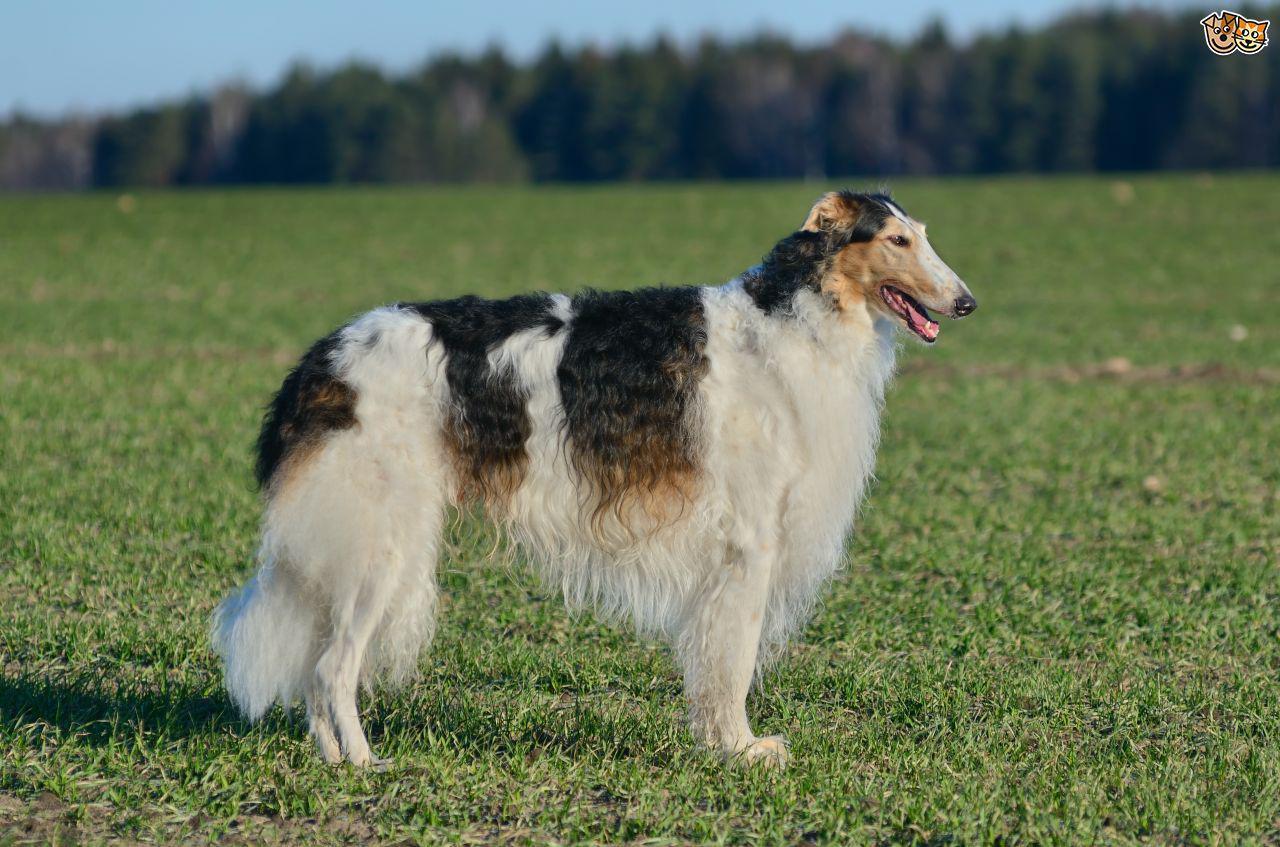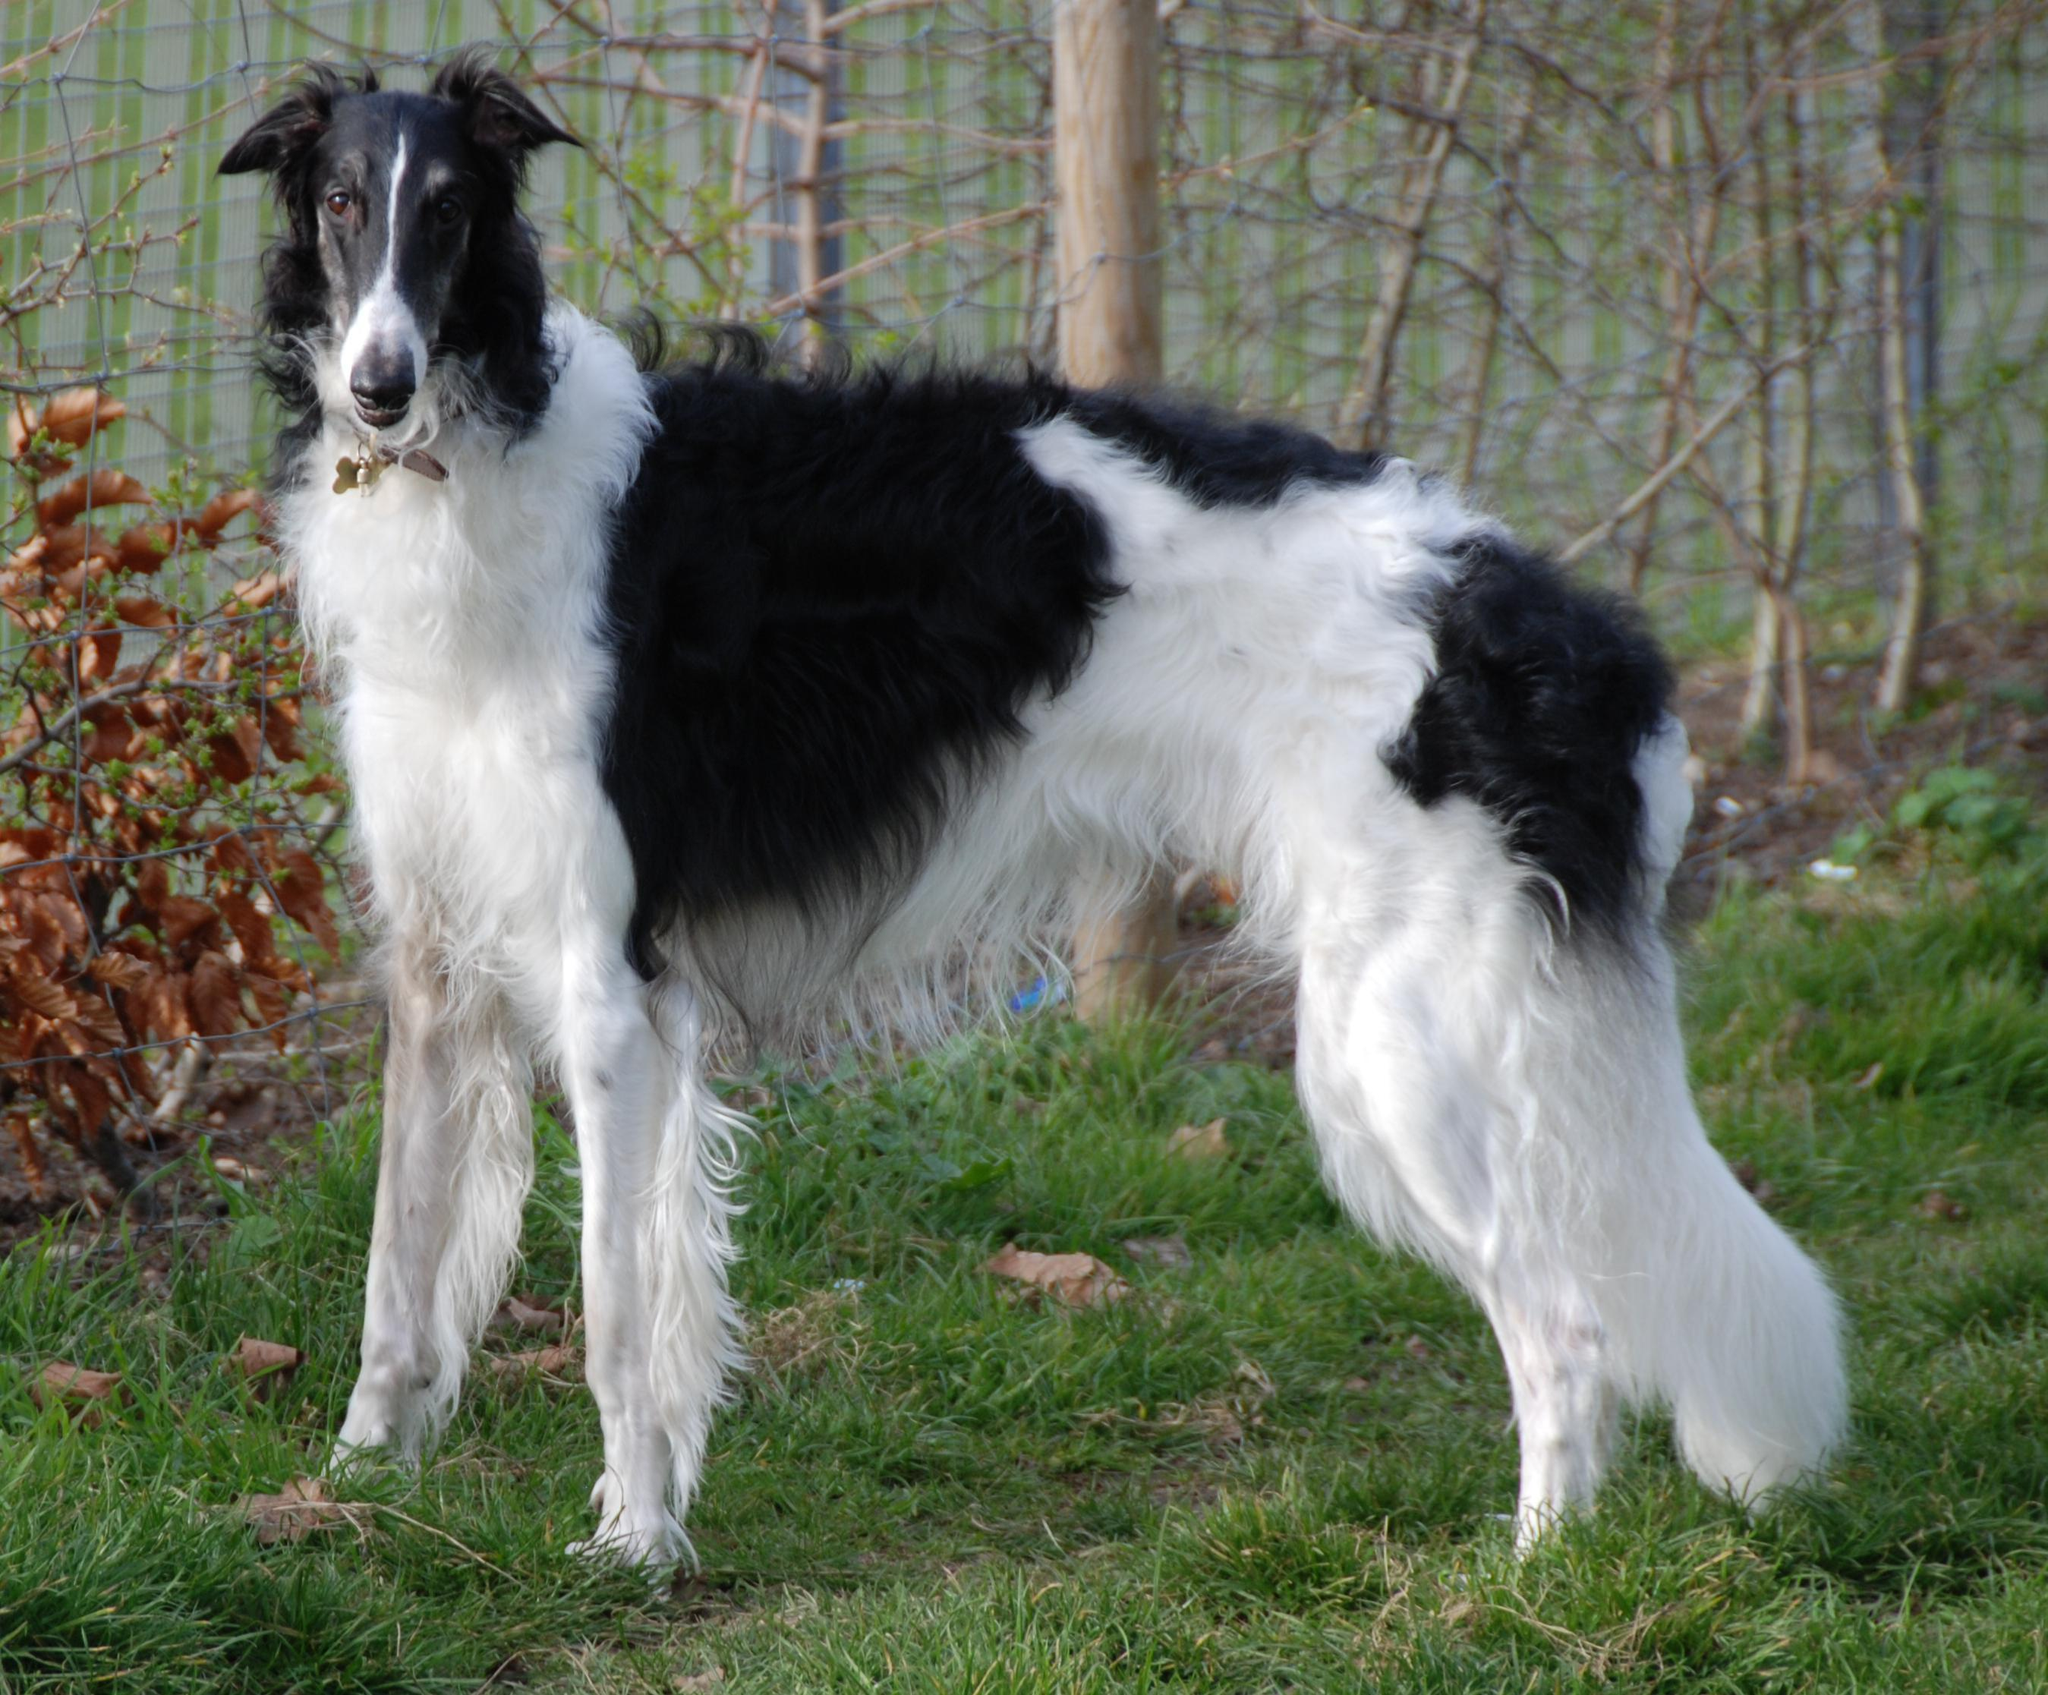The first image is the image on the left, the second image is the image on the right. Examine the images to the left and right. Is the description "The dog on the right is white with black spots." accurate? Answer yes or no. Yes. 